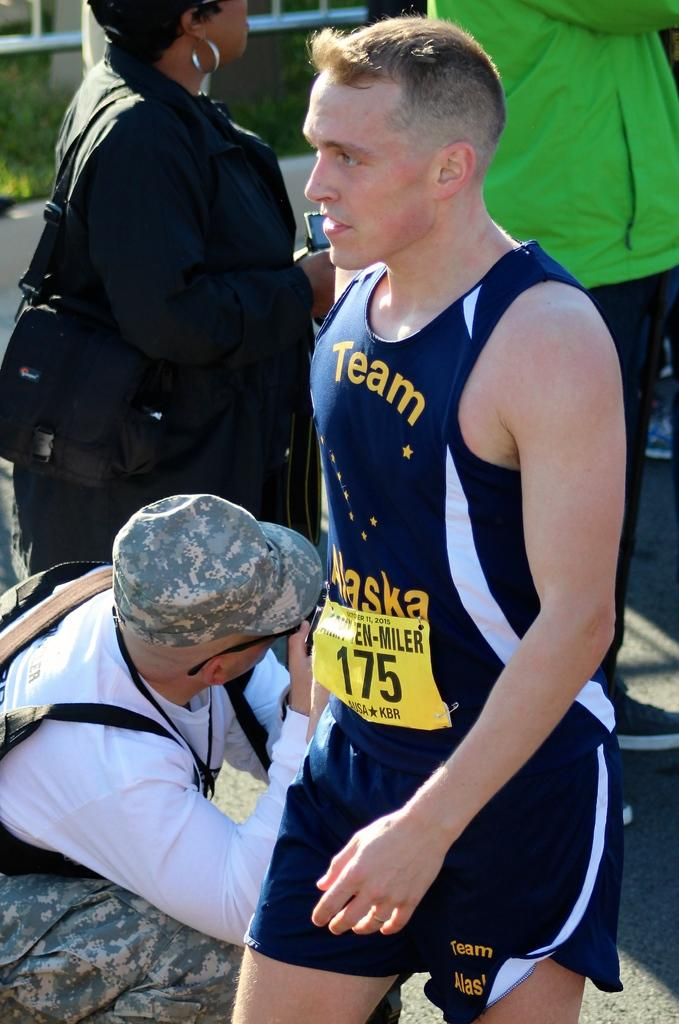<image>
Summarize the visual content of the image. Team Alaska reads the front of this athlete's uniform. 